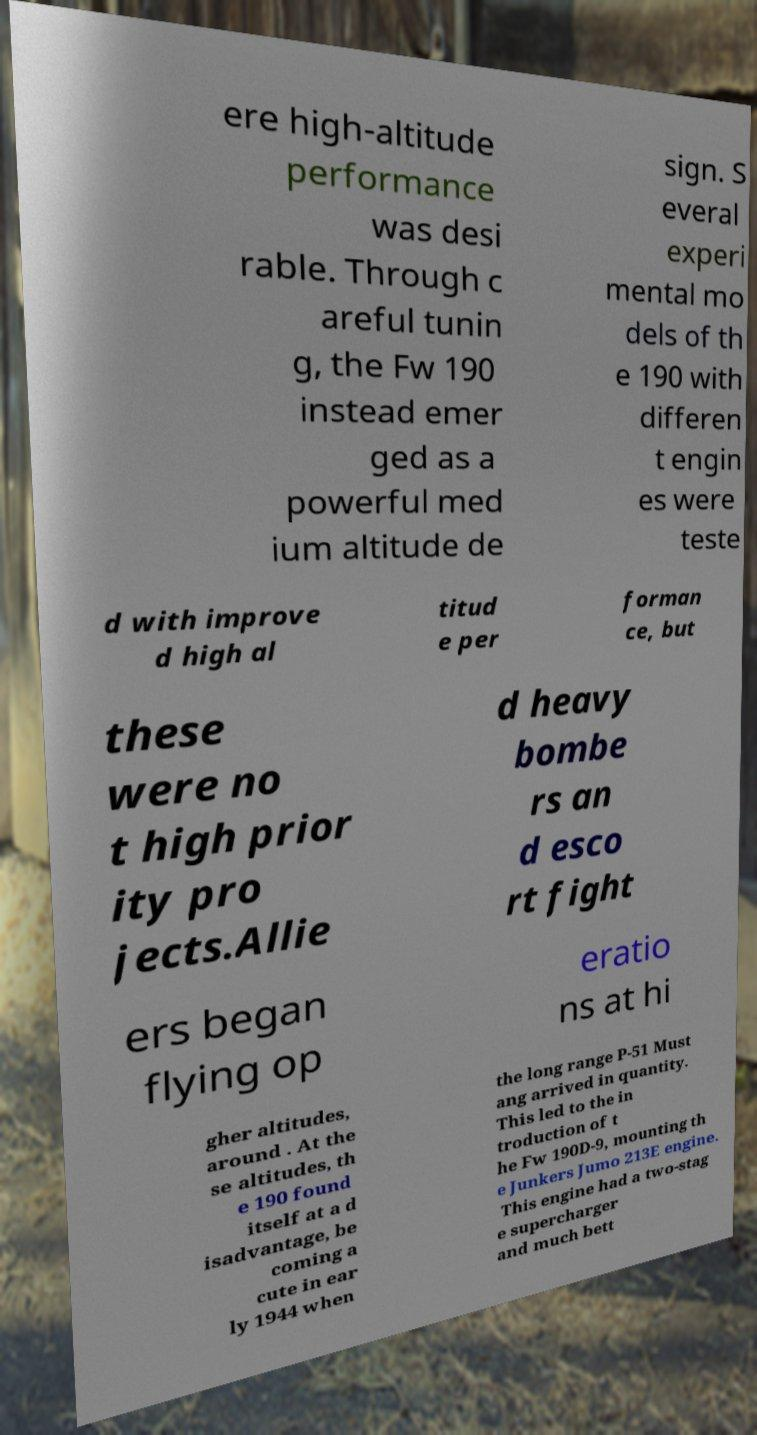Please read and relay the text visible in this image. What does it say? ere high-altitude performance was desi rable. Through c areful tunin g, the Fw 190 instead emer ged as a powerful med ium altitude de sign. S everal experi mental mo dels of th e 190 with differen t engin es were teste d with improve d high al titud e per forman ce, but these were no t high prior ity pro jects.Allie d heavy bombe rs an d esco rt fight ers began flying op eratio ns at hi gher altitudes, around . At the se altitudes, th e 190 found itself at a d isadvantage, be coming a cute in ear ly 1944 when the long range P-51 Must ang arrived in quantity. This led to the in troduction of t he Fw 190D-9, mounting th e Junkers Jumo 213E engine. This engine had a two-stag e supercharger and much bett 